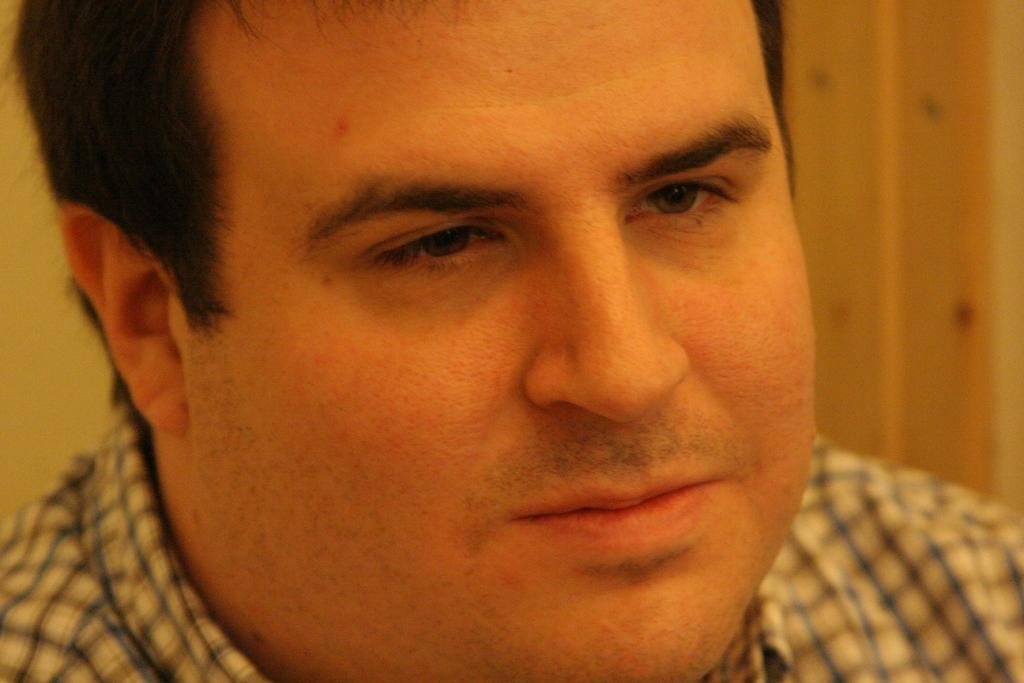Who is present in the image? There is a man in the image. What can be seen in the background of the image? There is a wall in the background of the image. What type of flight is the man taking in the image? There is no indication of a flight in the image; it only features a man and a wall in the background. 